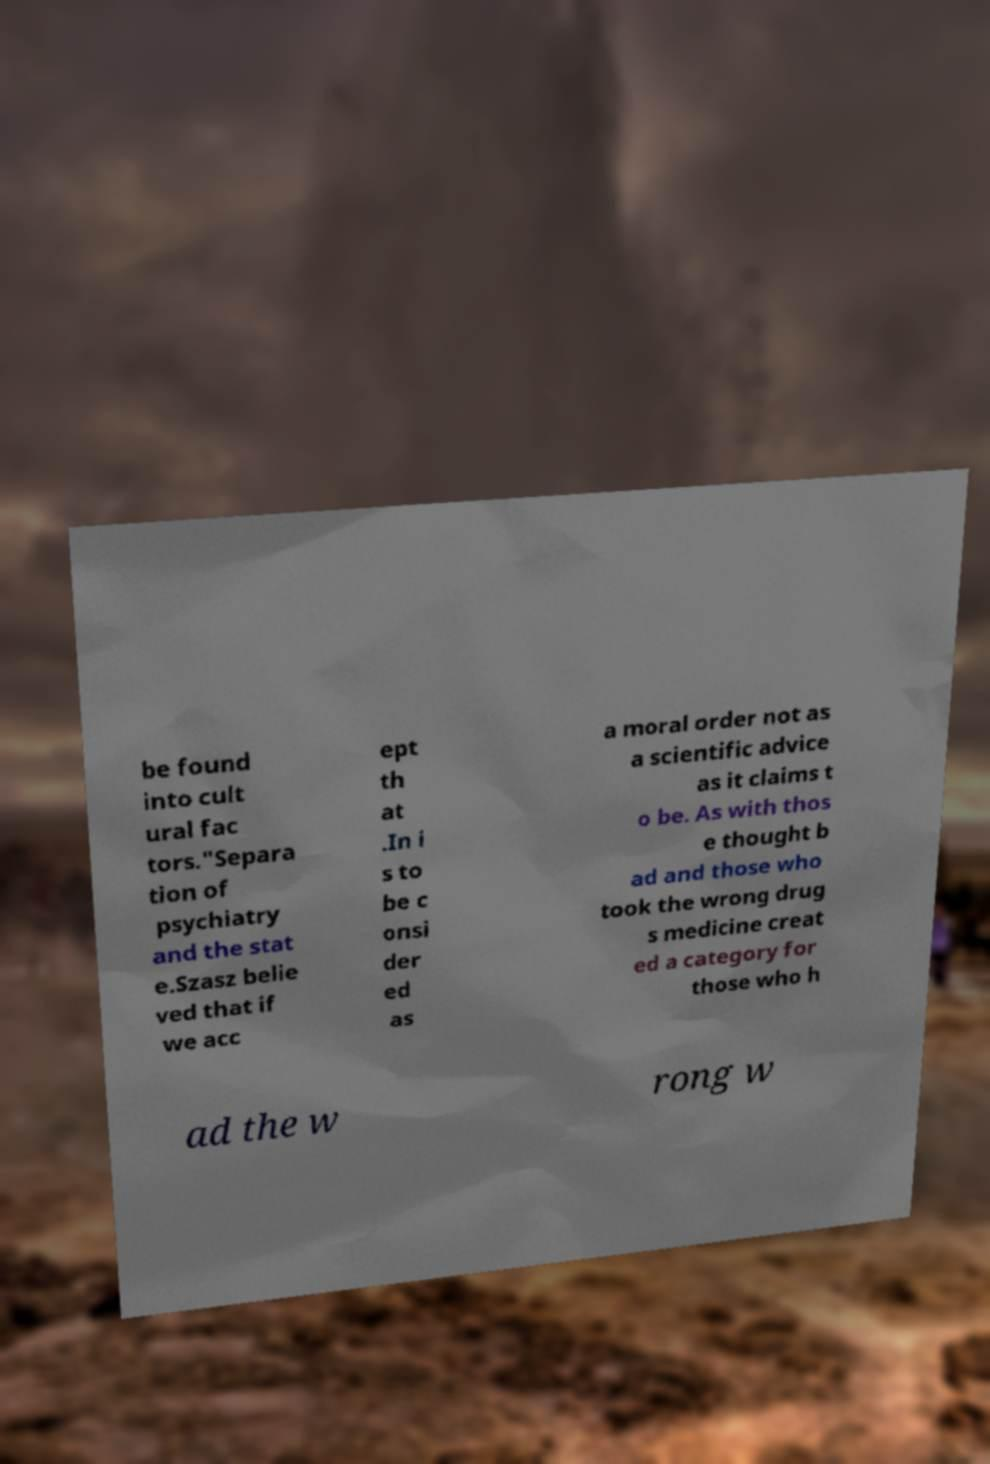Can you accurately transcribe the text from the provided image for me? be found into cult ural fac tors."Separa tion of psychiatry and the stat e.Szasz belie ved that if we acc ept th at .In i s to be c onsi der ed as a moral order not as a scientific advice as it claims t o be. As with thos e thought b ad and those who took the wrong drug s medicine creat ed a category for those who h ad the w rong w 